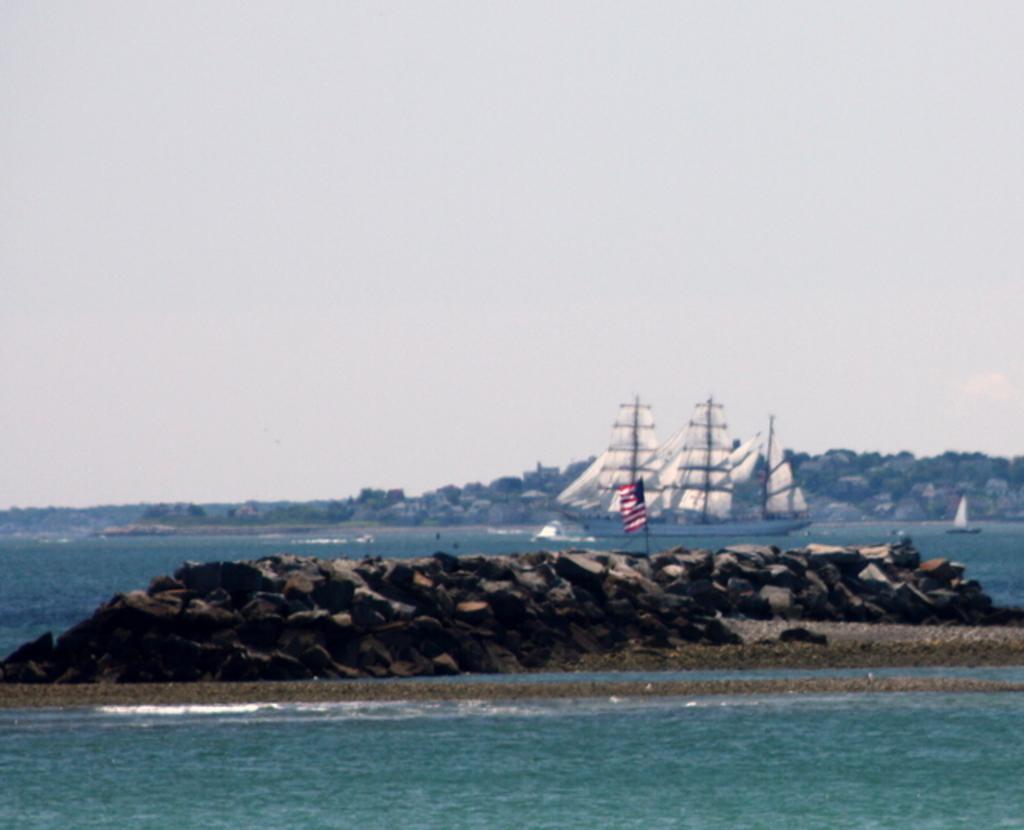Please provide a concise description of this image. In this image we can see water. Also there are rocks. And there is a flag with a pole. In the back there are boats on the water. In the background there is hill. Also there is sky. 